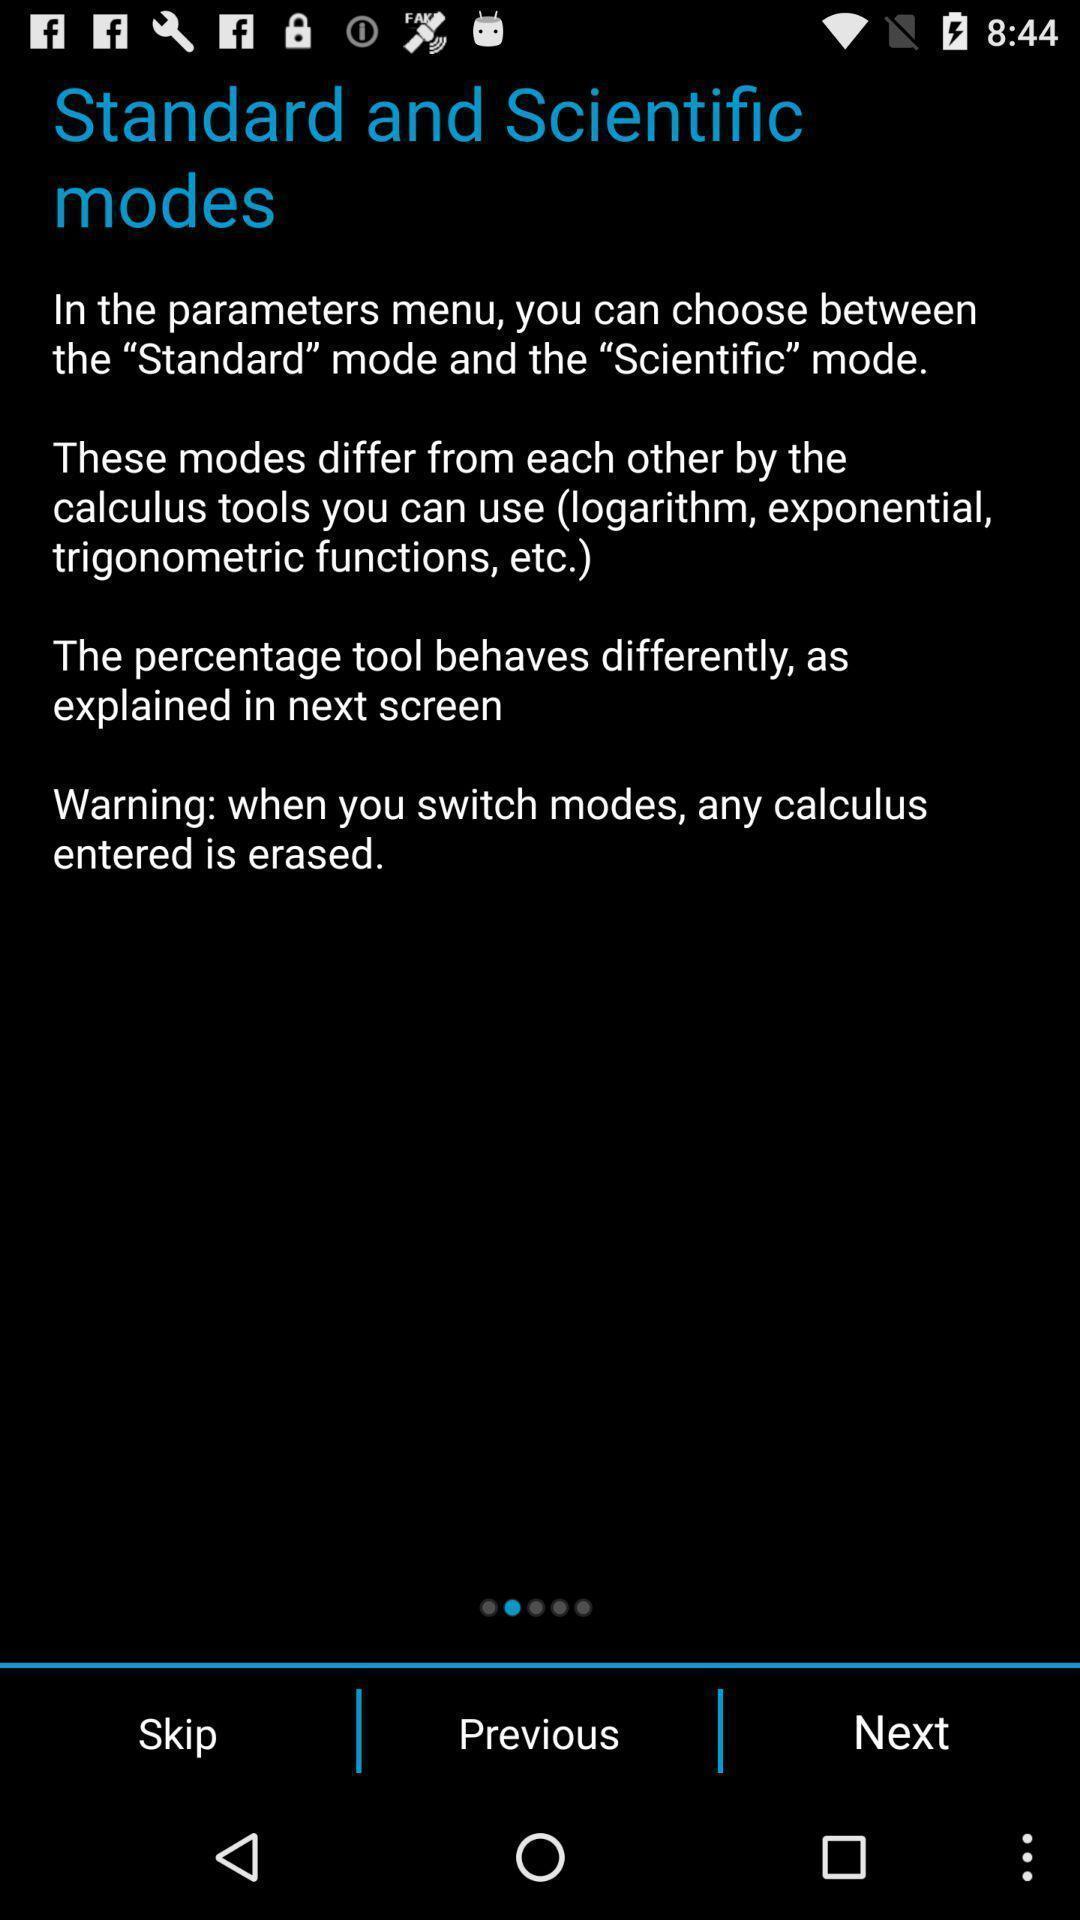Provide a detailed account of this screenshot. Page showing standarad and specific modes on an app. 